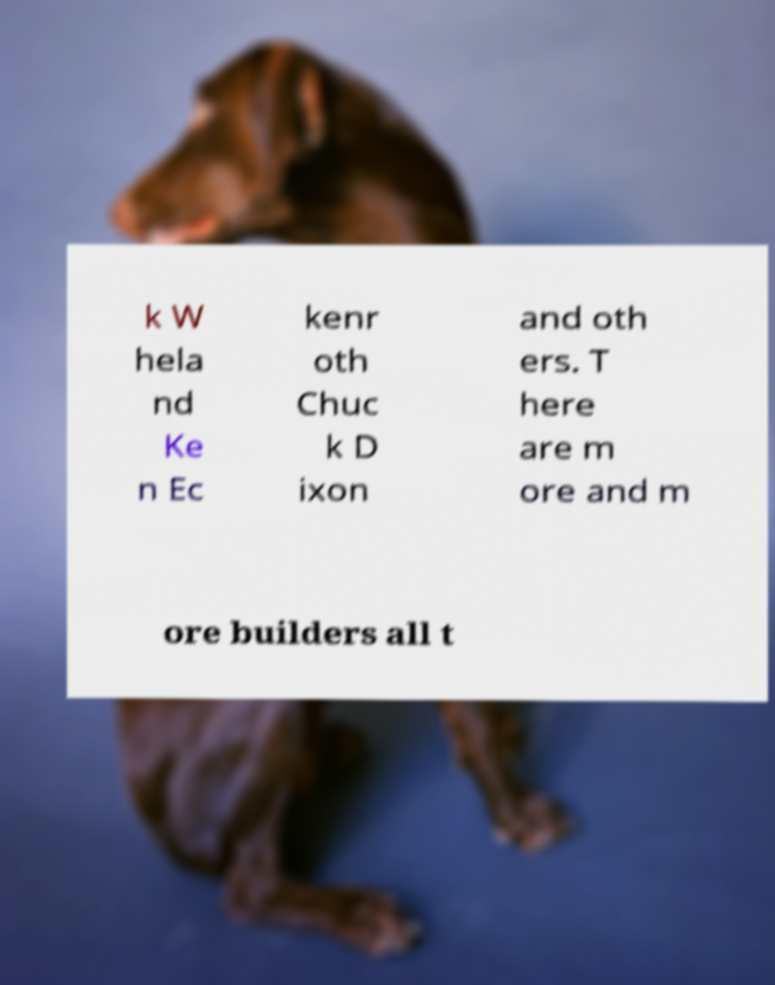What messages or text are displayed in this image? I need them in a readable, typed format. k W hela nd Ke n Ec kenr oth Chuc k D ixon and oth ers. T here are m ore and m ore builders all t 